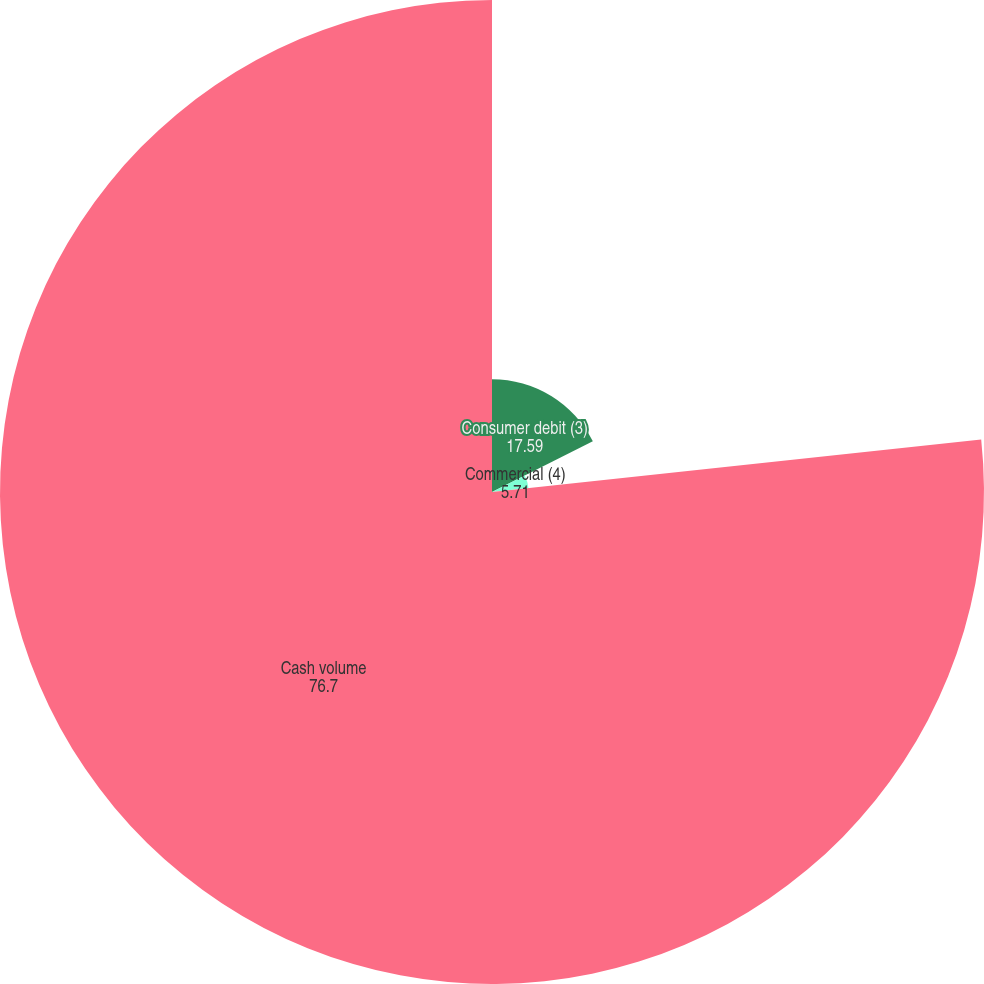Convert chart. <chart><loc_0><loc_0><loc_500><loc_500><pie_chart><fcel>Consumer debit (3)<fcel>Commercial (4)<fcel>Cash volume<nl><fcel>17.59%<fcel>5.71%<fcel>76.7%<nl></chart> 